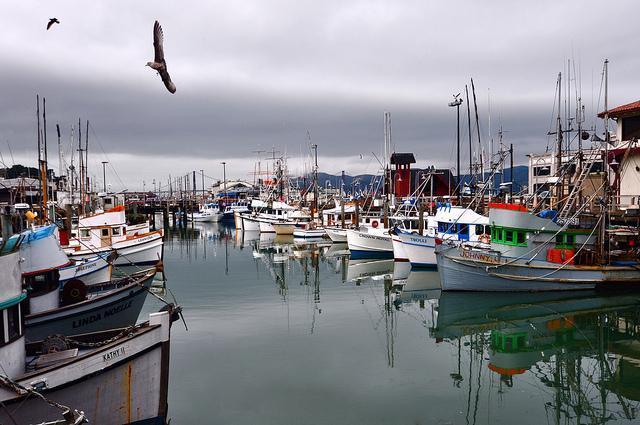How many boats can you see?
Give a very brief answer. 6. How many people gave facial hair in this picture?
Give a very brief answer. 0. 